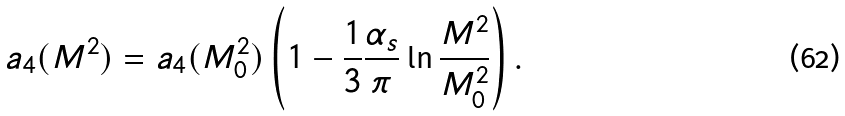<formula> <loc_0><loc_0><loc_500><loc_500>a _ { 4 } ( M ^ { 2 } ) = a _ { 4 } ( M _ { 0 } ^ { 2 } ) \left ( 1 - \frac { 1 } { 3 } \frac { \alpha _ { s } } { \pi } \ln \frac { M ^ { 2 } } { M _ { 0 } ^ { 2 } } \right ) .</formula> 